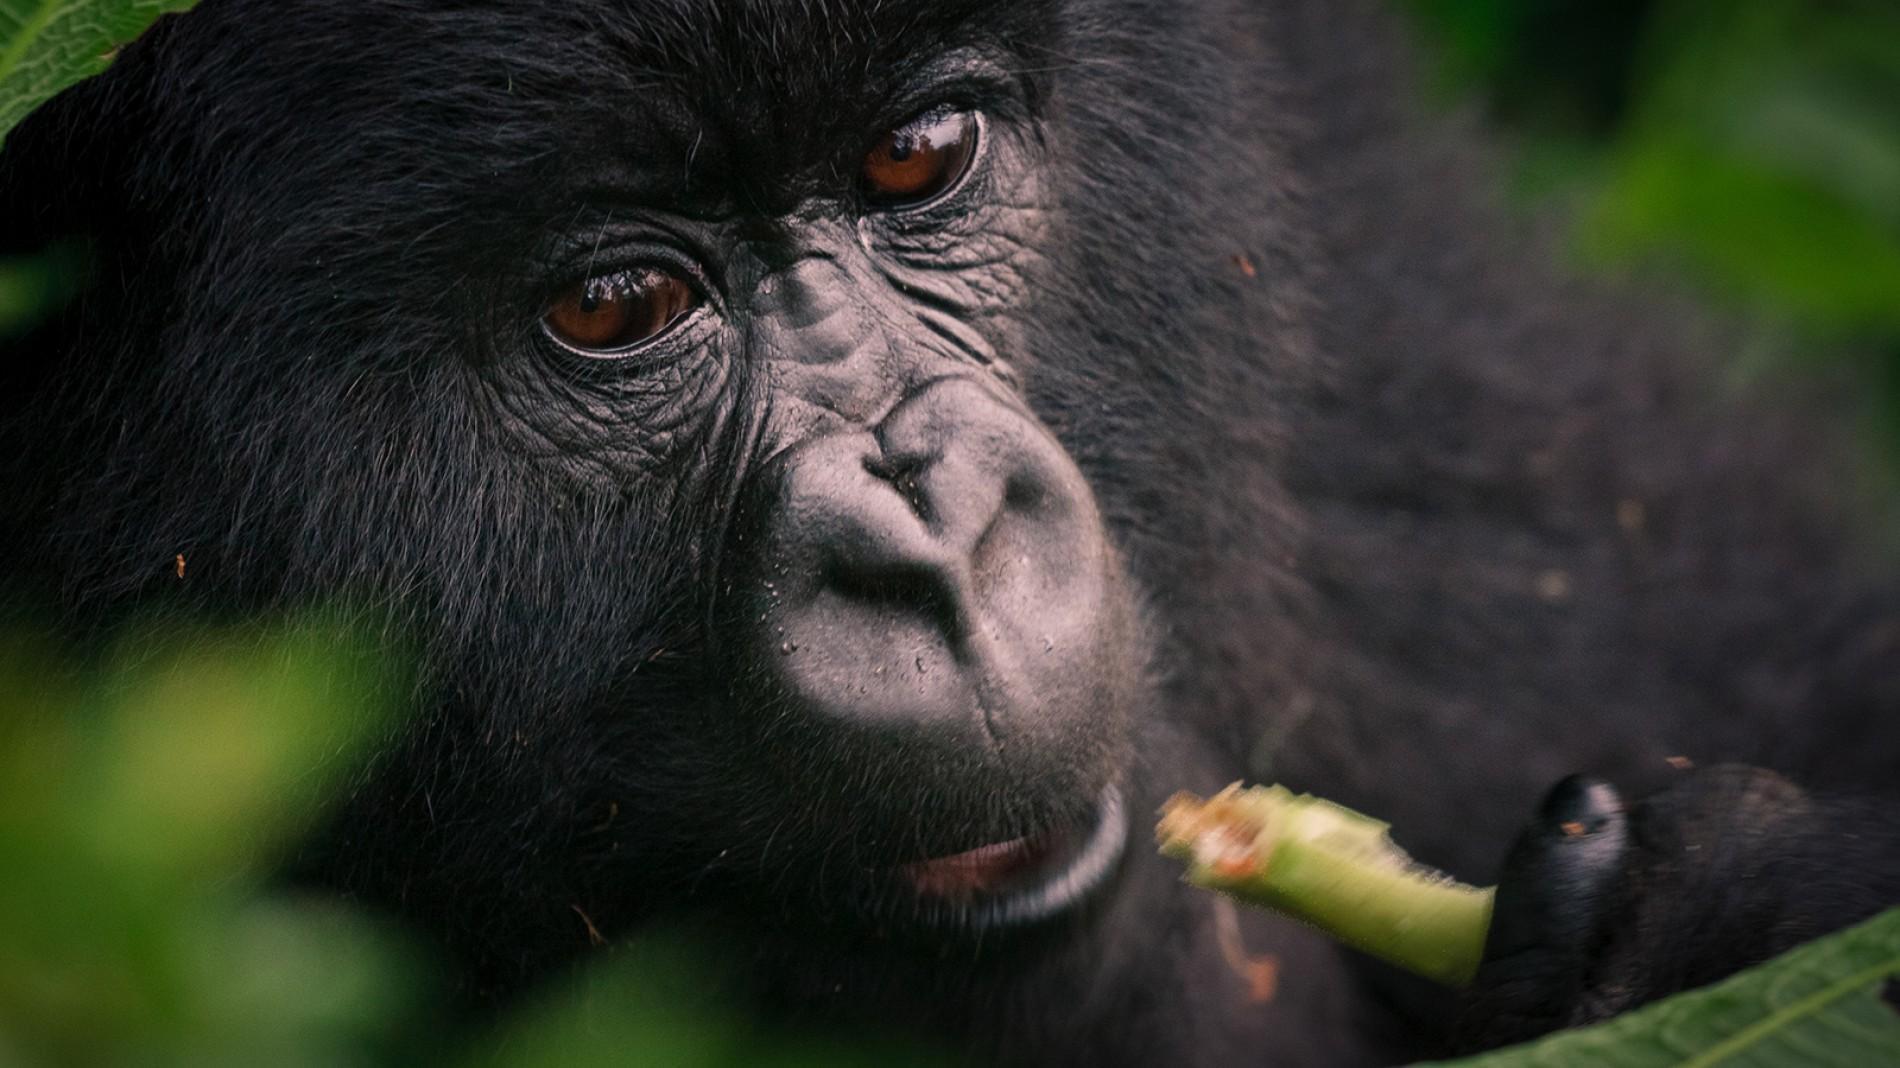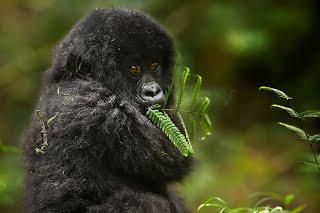The first image is the image on the left, the second image is the image on the right. For the images shown, is this caption "One of the images in the pair includes a baby gorilla." true? Answer yes or no. Yes. The first image is the image on the left, the second image is the image on the right. For the images displayed, is the sentence "The left image shows one gorilla holding a leafless stalk to its mouth, and the right image includes a fuzzy-haired young gorilla looking over its shoulder toward the camera." factually correct? Answer yes or no. Yes. 